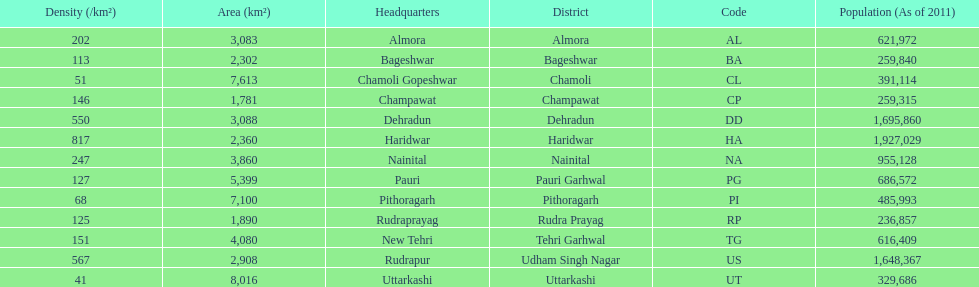What is the last code listed? UT. 